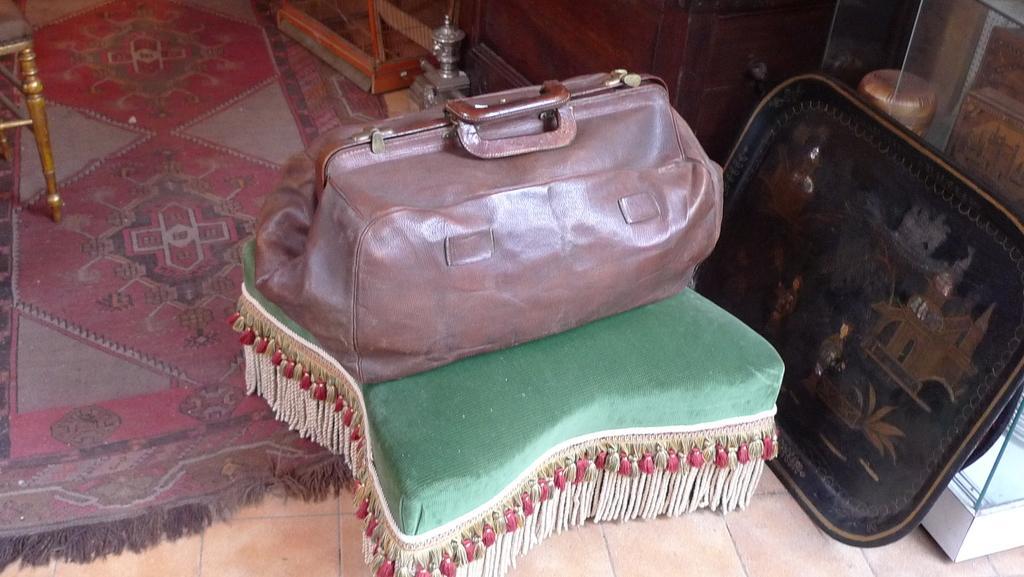Describe this image in one or two sentences. In this image I can see a table. On table there is a bag. 